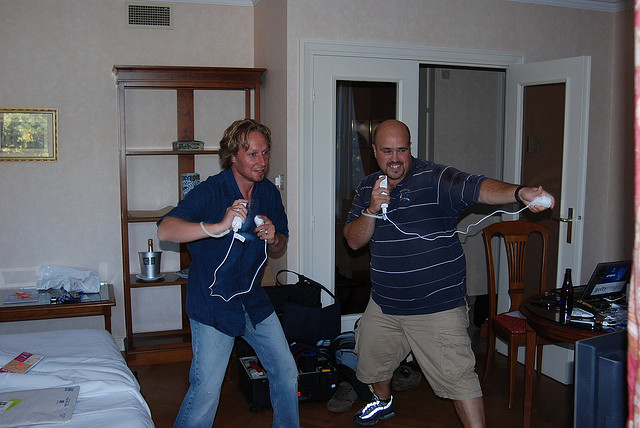<image>Whose shirt is green? No one's shirt is green in the image. Whose shirt is green? No one's shirt is green. It can be seen that nobody is wearing a green shirt. 